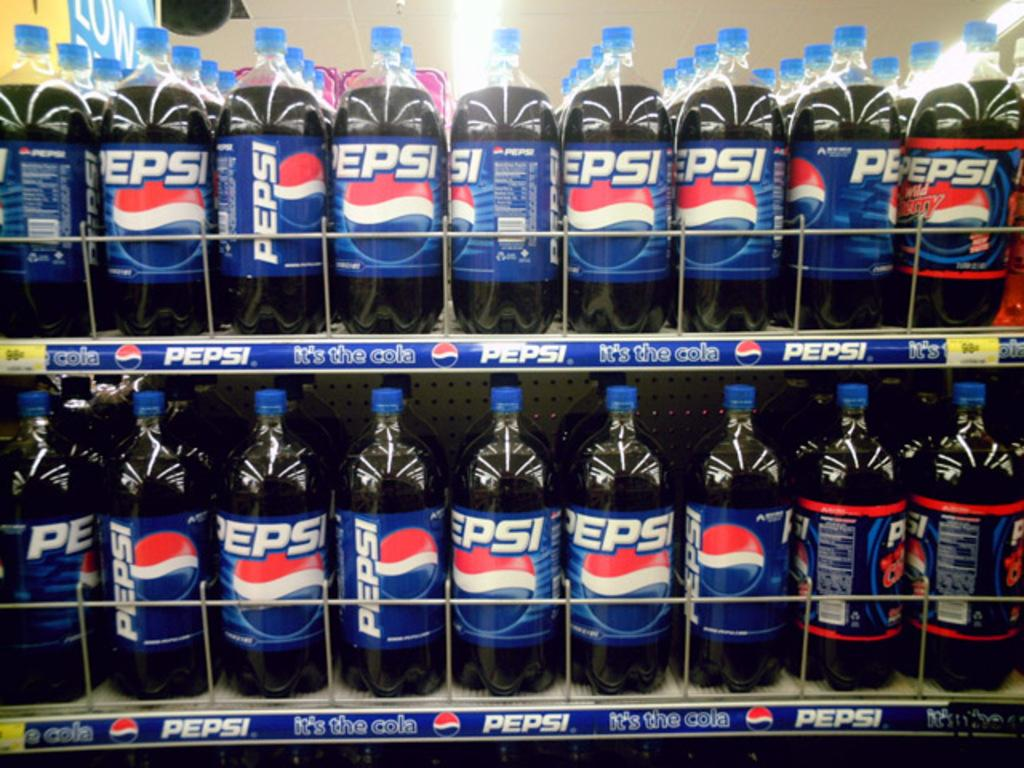Provide a one-sentence caption for the provided image. a super market isle full of pepsi products on both top and bottom. 